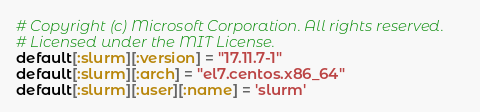Convert code to text. <code><loc_0><loc_0><loc_500><loc_500><_Ruby_># Copyright (c) Microsoft Corporation. All rights reserved.
# Licensed under the MIT License.
default[:slurm][:version] = "17.11.7-1"
default[:slurm][:arch] = "el7.centos.x86_64"
default[:slurm][:user][:name] = 'slurm'
</code> 